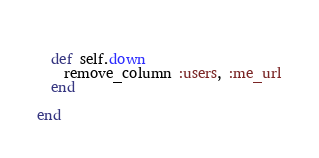Convert code to text. <code><loc_0><loc_0><loc_500><loc_500><_Ruby_>  
  def self.down
    remove_column :users, :me_url
  end
  
end</code> 